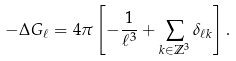<formula> <loc_0><loc_0><loc_500><loc_500>- \Delta G _ { \ell } = 4 \pi \left [ - \frac { 1 } { \ell ^ { 3 } } + \sum _ { k \in \mathbb { Z } ^ { 3 } } \delta _ { \ell k } \right ] .</formula> 